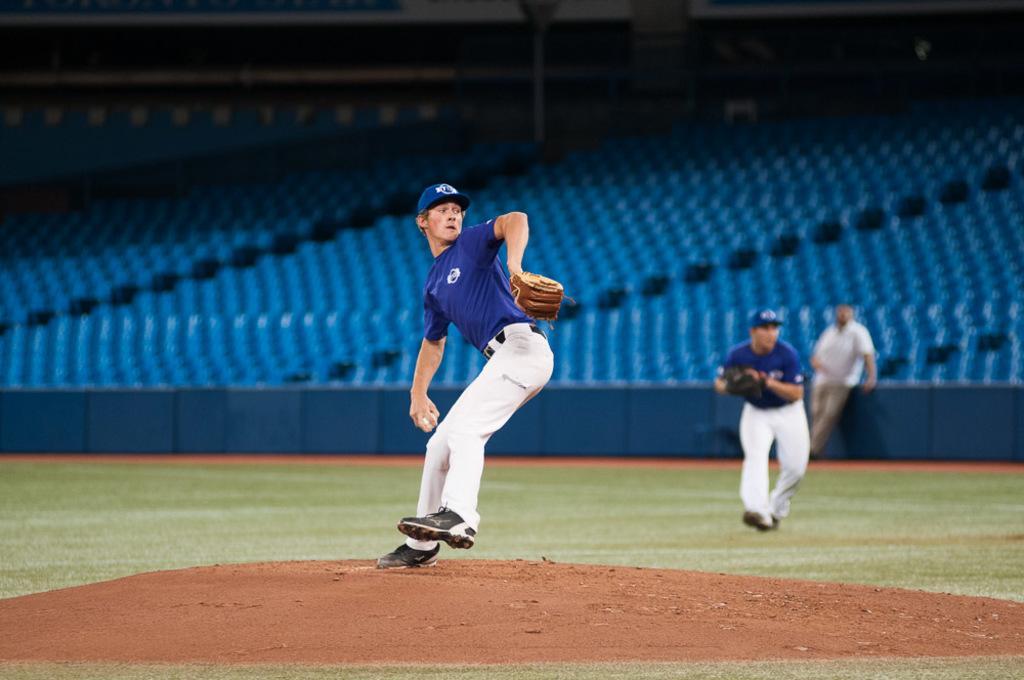In one or two sentences, can you explain what this image depicts? In this image we can see three people, two of them are playing baseball, one person is holding a ball, behind them, we can see some seats, and the background is blurred. 